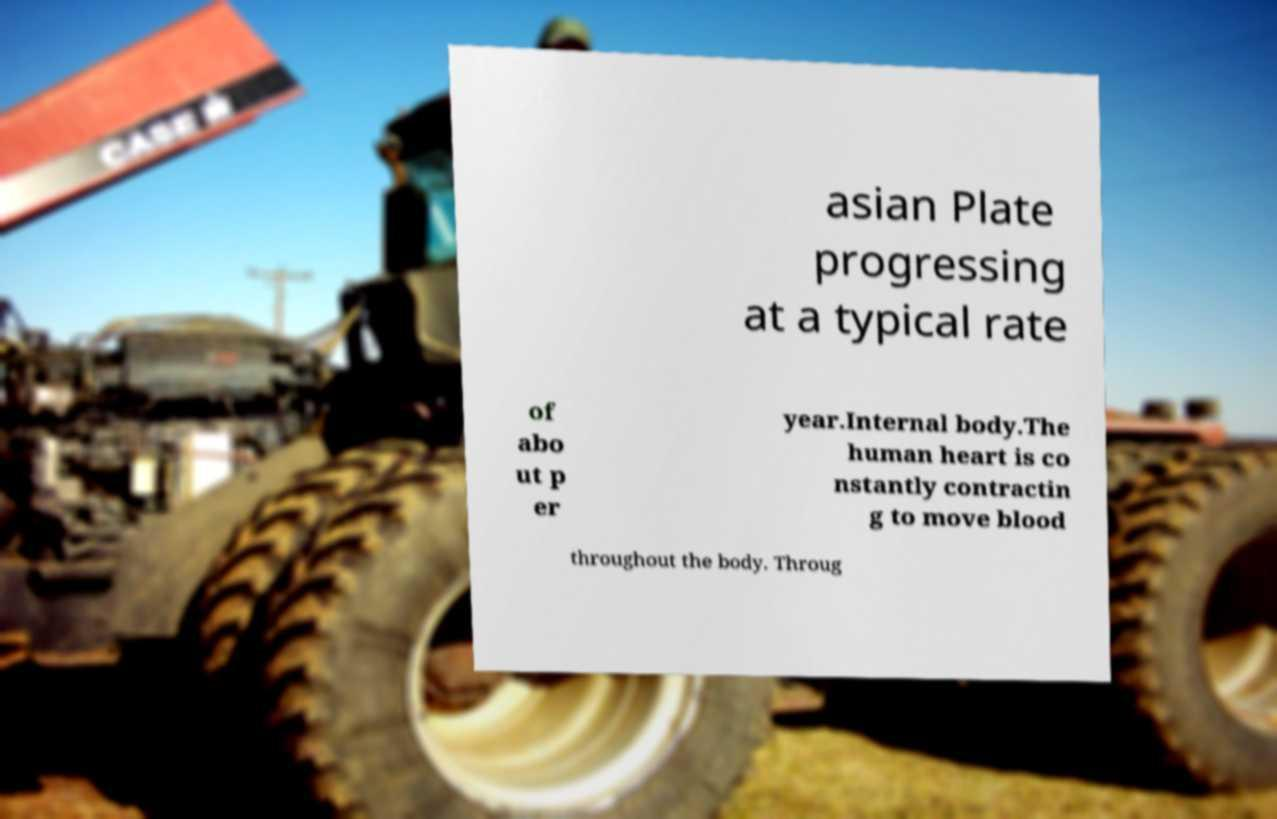For documentation purposes, I need the text within this image transcribed. Could you provide that? asian Plate progressing at a typical rate of abo ut p er year.Internal body.The human heart is co nstantly contractin g to move blood throughout the body. Throug 